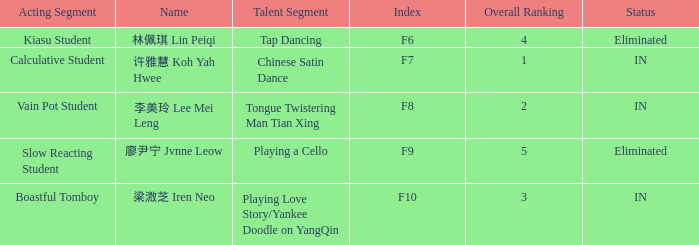For the event with index f7, what is the status? IN. 